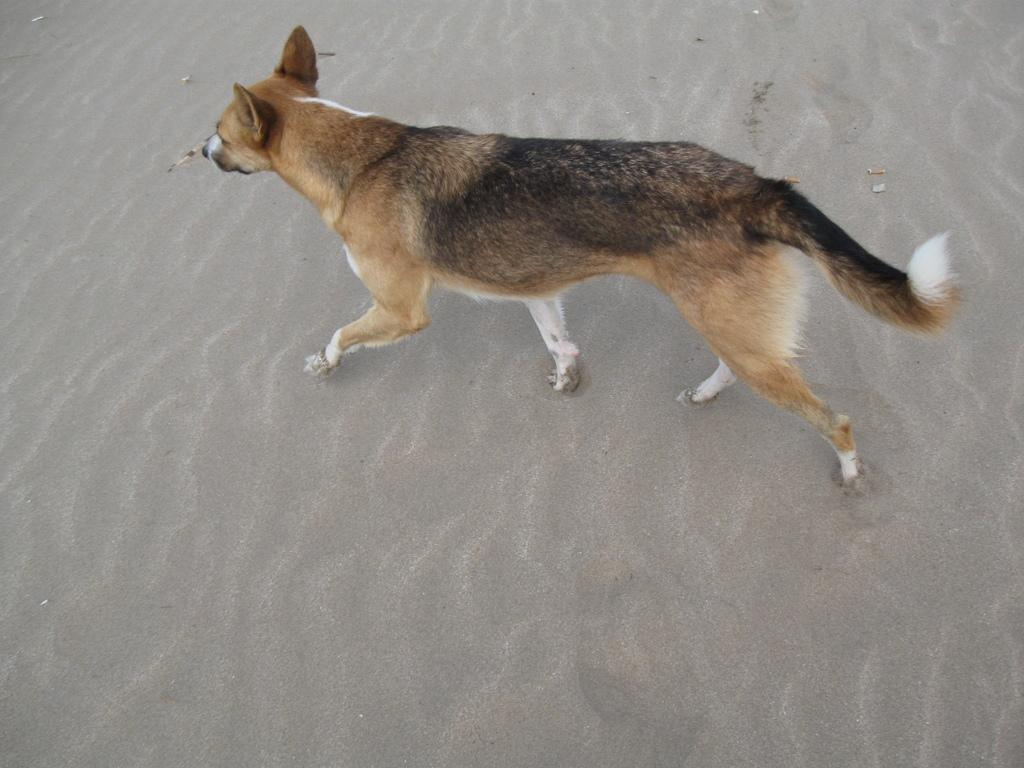What animal is present in the image? There is a dog in the image. What type of terrain is the dog walking on? The dog is walking on the sand. What type of lumber is the dog carrying in its mouth in the image? There is no lumber present in the image; the dog is simply walking on the sand. 